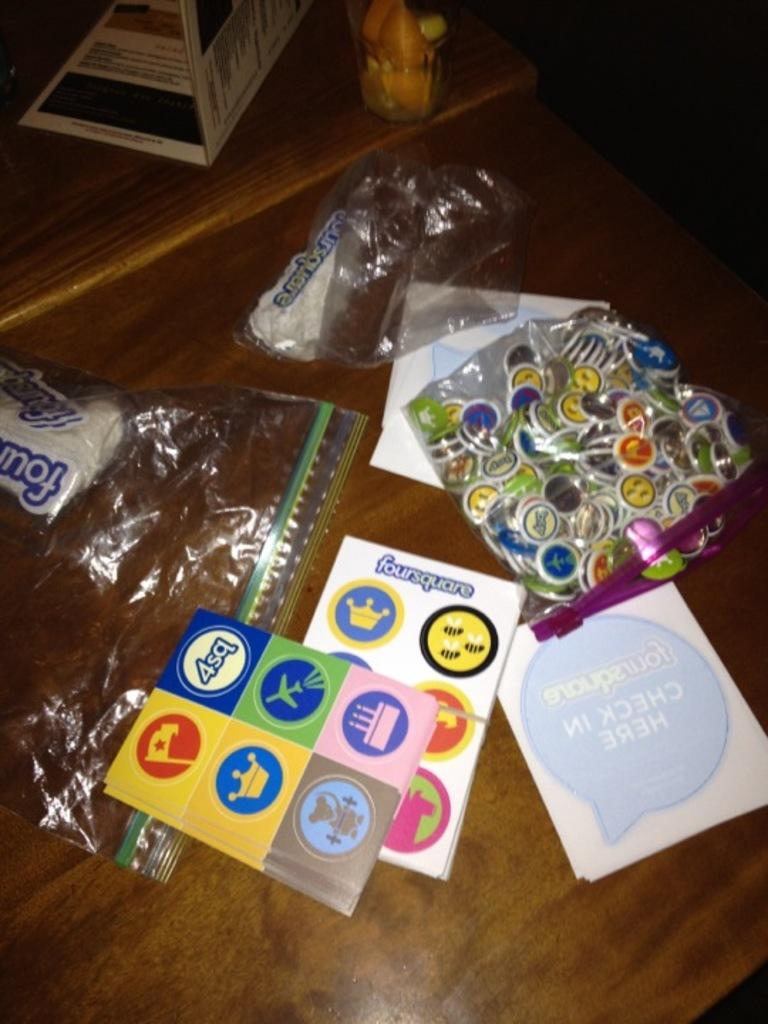What type of objects can be seen on the table in the image? There are books, packets, and stickers on the table. Are there any other items on the table besides the ones mentioned? Yes, there are other unspecified items on the table. What type of nut is used to hold the desk together in the image? There is no desk present in the image, and therefore no nuts can be observed. What month is depicted in the image? The image does not depict a specific month or time of year. 